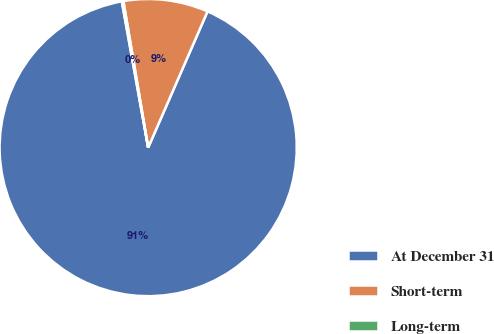Convert chart. <chart><loc_0><loc_0><loc_500><loc_500><pie_chart><fcel>At December 31<fcel>Short-term<fcel>Long-term<nl><fcel>90.62%<fcel>9.21%<fcel>0.17%<nl></chart> 